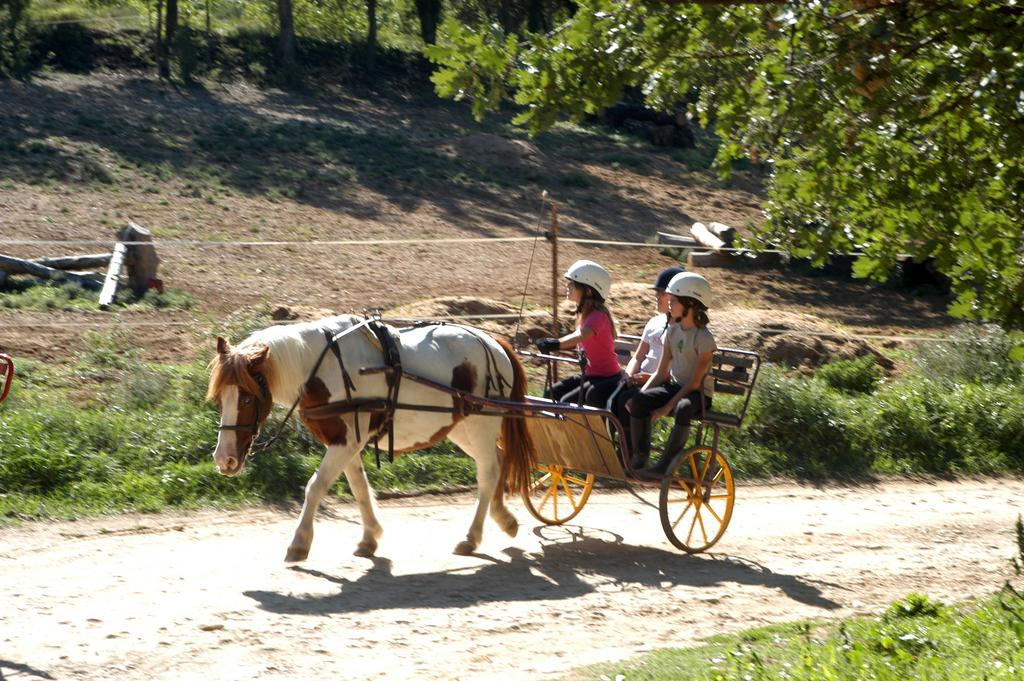Who is present in the image? There are kids in the image. What are the kids wearing on their heads? The kids are wearing helmets. What are the kids sitting on in the image? The kids are sitting on a horse cart. What is located beside the horse cart? There is a fence beside the horse cart. What can be seen in the distance in the image? There are trees in the background of the image. What type of mist can be seen surrounding the horse cart in the image? There is no mist present in the image; it is a clear day with no fog or mist. 